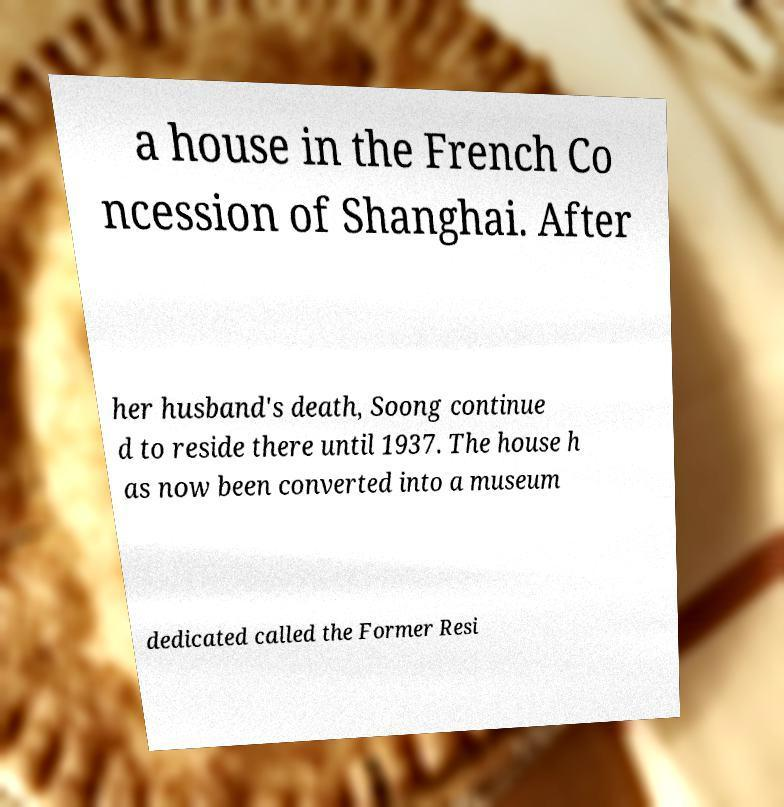For documentation purposes, I need the text within this image transcribed. Could you provide that? a house in the French Co ncession of Shanghai. After her husband's death, Soong continue d to reside there until 1937. The house h as now been converted into a museum dedicated called the Former Resi 